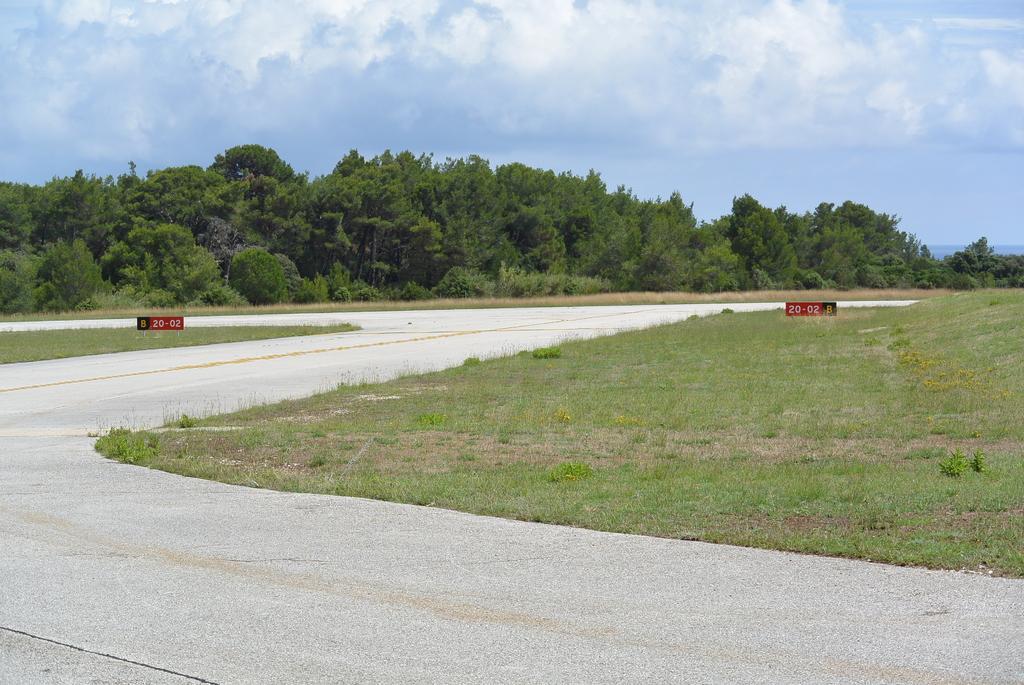Describe this image in one or two sentences. In this image I can see the road. To the side of the road I can see the grass and there are some red color boards can be seen. In the background I can see many trees, clouds and the sky. 